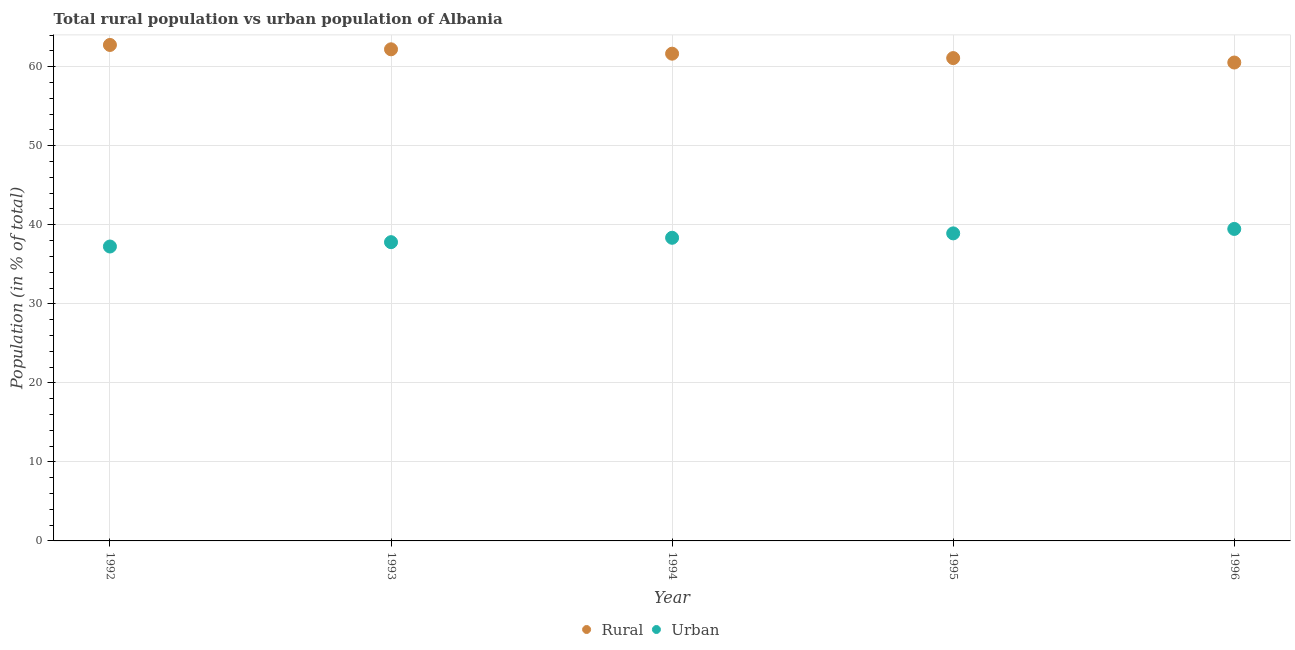How many different coloured dotlines are there?
Offer a very short reply. 2. Is the number of dotlines equal to the number of legend labels?
Your response must be concise. Yes. What is the urban population in 1993?
Offer a very short reply. 37.8. Across all years, what is the maximum rural population?
Give a very brief answer. 62.75. Across all years, what is the minimum rural population?
Offer a terse response. 60.53. In which year was the rural population maximum?
Ensure brevity in your answer.  1992. What is the total rural population in the graph?
Make the answer very short. 308.21. What is the difference between the rural population in 1995 and that in 1996?
Offer a very short reply. 0.56. What is the difference between the rural population in 1993 and the urban population in 1992?
Provide a short and direct response. 24.95. What is the average urban population per year?
Provide a short and direct response. 38.36. In the year 1996, what is the difference between the urban population and rural population?
Your answer should be very brief. -21.05. What is the ratio of the rural population in 1992 to that in 1995?
Offer a terse response. 1.03. Is the difference between the rural population in 1993 and 1994 greater than the difference between the urban population in 1993 and 1994?
Provide a short and direct response. Yes. What is the difference between the highest and the second highest urban population?
Your answer should be compact. 0.56. What is the difference between the highest and the lowest urban population?
Make the answer very short. 2.22. In how many years, is the rural population greater than the average rural population taken over all years?
Your response must be concise. 3. Does the rural population monotonically increase over the years?
Ensure brevity in your answer.  No. How many dotlines are there?
Your response must be concise. 2. Does the graph contain any zero values?
Give a very brief answer. No. Does the graph contain grids?
Your response must be concise. Yes. How many legend labels are there?
Offer a very short reply. 2. What is the title of the graph?
Your answer should be very brief. Total rural population vs urban population of Albania. Does "US$" appear as one of the legend labels in the graph?
Keep it short and to the point. No. What is the label or title of the Y-axis?
Provide a short and direct response. Population (in % of total). What is the Population (in % of total) in Rural in 1992?
Provide a short and direct response. 62.75. What is the Population (in % of total) in Urban in 1992?
Give a very brief answer. 37.25. What is the Population (in % of total) in Rural in 1993?
Provide a succinct answer. 62.2. What is the Population (in % of total) of Urban in 1993?
Give a very brief answer. 37.8. What is the Population (in % of total) of Rural in 1994?
Ensure brevity in your answer.  61.65. What is the Population (in % of total) of Urban in 1994?
Your answer should be compact. 38.35. What is the Population (in % of total) of Rural in 1995?
Offer a terse response. 61.09. What is the Population (in % of total) in Urban in 1995?
Give a very brief answer. 38.91. What is the Population (in % of total) in Rural in 1996?
Keep it short and to the point. 60.53. What is the Population (in % of total) of Urban in 1996?
Provide a short and direct response. 39.47. Across all years, what is the maximum Population (in % of total) in Rural?
Make the answer very short. 62.75. Across all years, what is the maximum Population (in % of total) of Urban?
Give a very brief answer. 39.47. Across all years, what is the minimum Population (in % of total) of Rural?
Your answer should be compact. 60.53. Across all years, what is the minimum Population (in % of total) of Urban?
Your response must be concise. 37.25. What is the total Population (in % of total) of Rural in the graph?
Provide a succinct answer. 308.21. What is the total Population (in % of total) of Urban in the graph?
Give a very brief answer. 191.79. What is the difference between the Population (in % of total) of Rural in 1992 and that in 1993?
Offer a very short reply. 0.55. What is the difference between the Population (in % of total) in Urban in 1992 and that in 1993?
Your answer should be very brief. -0.55. What is the difference between the Population (in % of total) of Rural in 1992 and that in 1994?
Give a very brief answer. 1.1. What is the difference between the Population (in % of total) in Urban in 1992 and that in 1994?
Provide a short and direct response. -1.1. What is the difference between the Population (in % of total) of Rural in 1992 and that in 1995?
Ensure brevity in your answer.  1.66. What is the difference between the Population (in % of total) of Urban in 1992 and that in 1995?
Offer a terse response. -1.66. What is the difference between the Population (in % of total) in Rural in 1992 and that in 1996?
Provide a short and direct response. 2.22. What is the difference between the Population (in % of total) in Urban in 1992 and that in 1996?
Give a very brief answer. -2.22. What is the difference between the Population (in % of total) of Rural in 1993 and that in 1994?
Your answer should be compact. 0.56. What is the difference between the Population (in % of total) in Urban in 1993 and that in 1994?
Give a very brief answer. -0.56. What is the difference between the Population (in % of total) of Rural in 1993 and that in 1995?
Your answer should be compact. 1.11. What is the difference between the Population (in % of total) in Urban in 1993 and that in 1995?
Keep it short and to the point. -1.11. What is the difference between the Population (in % of total) of Rural in 1993 and that in 1996?
Your answer should be compact. 1.67. What is the difference between the Population (in % of total) in Urban in 1993 and that in 1996?
Make the answer very short. -1.67. What is the difference between the Population (in % of total) of Rural in 1994 and that in 1995?
Make the answer very short. 0.56. What is the difference between the Population (in % of total) of Urban in 1994 and that in 1995?
Keep it short and to the point. -0.56. What is the difference between the Population (in % of total) of Rural in 1994 and that in 1996?
Your answer should be very brief. 1.12. What is the difference between the Population (in % of total) in Urban in 1994 and that in 1996?
Make the answer very short. -1.12. What is the difference between the Population (in % of total) of Rural in 1995 and that in 1996?
Make the answer very short. 0.56. What is the difference between the Population (in % of total) of Urban in 1995 and that in 1996?
Your response must be concise. -0.56. What is the difference between the Population (in % of total) of Rural in 1992 and the Population (in % of total) of Urban in 1993?
Offer a terse response. 24.95. What is the difference between the Population (in % of total) of Rural in 1992 and the Population (in % of total) of Urban in 1994?
Give a very brief answer. 24.4. What is the difference between the Population (in % of total) in Rural in 1992 and the Population (in % of total) in Urban in 1995?
Make the answer very short. 23.84. What is the difference between the Population (in % of total) of Rural in 1992 and the Population (in % of total) of Urban in 1996?
Ensure brevity in your answer.  23.28. What is the difference between the Population (in % of total) in Rural in 1993 and the Population (in % of total) in Urban in 1994?
Your answer should be compact. 23.85. What is the difference between the Population (in % of total) in Rural in 1993 and the Population (in % of total) in Urban in 1995?
Offer a very short reply. 23.29. What is the difference between the Population (in % of total) in Rural in 1993 and the Population (in % of total) in Urban in 1996?
Provide a short and direct response. 22.73. What is the difference between the Population (in % of total) in Rural in 1994 and the Population (in % of total) in Urban in 1995?
Provide a short and direct response. 22.73. What is the difference between the Population (in % of total) in Rural in 1994 and the Population (in % of total) in Urban in 1996?
Your answer should be compact. 22.17. What is the difference between the Population (in % of total) of Rural in 1995 and the Population (in % of total) of Urban in 1996?
Offer a terse response. 21.62. What is the average Population (in % of total) in Rural per year?
Provide a succinct answer. 61.64. What is the average Population (in % of total) of Urban per year?
Ensure brevity in your answer.  38.36. In the year 1992, what is the difference between the Population (in % of total) of Rural and Population (in % of total) of Urban?
Give a very brief answer. 25.5. In the year 1993, what is the difference between the Population (in % of total) of Rural and Population (in % of total) of Urban?
Ensure brevity in your answer.  24.4. In the year 1994, what is the difference between the Population (in % of total) in Rural and Population (in % of total) in Urban?
Provide a succinct answer. 23.29. In the year 1995, what is the difference between the Population (in % of total) in Rural and Population (in % of total) in Urban?
Give a very brief answer. 22.18. In the year 1996, what is the difference between the Population (in % of total) of Rural and Population (in % of total) of Urban?
Keep it short and to the point. 21.05. What is the ratio of the Population (in % of total) in Rural in 1992 to that in 1993?
Provide a short and direct response. 1.01. What is the ratio of the Population (in % of total) of Urban in 1992 to that in 1993?
Offer a very short reply. 0.99. What is the ratio of the Population (in % of total) of Rural in 1992 to that in 1994?
Offer a terse response. 1.02. What is the ratio of the Population (in % of total) of Urban in 1992 to that in 1994?
Keep it short and to the point. 0.97. What is the ratio of the Population (in % of total) of Rural in 1992 to that in 1995?
Ensure brevity in your answer.  1.03. What is the ratio of the Population (in % of total) of Urban in 1992 to that in 1995?
Make the answer very short. 0.96. What is the ratio of the Population (in % of total) in Rural in 1992 to that in 1996?
Provide a succinct answer. 1.04. What is the ratio of the Population (in % of total) of Urban in 1992 to that in 1996?
Your answer should be very brief. 0.94. What is the ratio of the Population (in % of total) in Rural in 1993 to that in 1994?
Make the answer very short. 1.01. What is the ratio of the Population (in % of total) in Urban in 1993 to that in 1994?
Ensure brevity in your answer.  0.99. What is the ratio of the Population (in % of total) of Rural in 1993 to that in 1995?
Provide a short and direct response. 1.02. What is the ratio of the Population (in % of total) in Urban in 1993 to that in 1995?
Ensure brevity in your answer.  0.97. What is the ratio of the Population (in % of total) of Rural in 1993 to that in 1996?
Ensure brevity in your answer.  1.03. What is the ratio of the Population (in % of total) of Urban in 1993 to that in 1996?
Ensure brevity in your answer.  0.96. What is the ratio of the Population (in % of total) of Rural in 1994 to that in 1995?
Offer a very short reply. 1.01. What is the ratio of the Population (in % of total) in Urban in 1994 to that in 1995?
Offer a very short reply. 0.99. What is the ratio of the Population (in % of total) in Rural in 1994 to that in 1996?
Your answer should be compact. 1.02. What is the ratio of the Population (in % of total) in Urban in 1994 to that in 1996?
Your answer should be compact. 0.97. What is the ratio of the Population (in % of total) of Rural in 1995 to that in 1996?
Keep it short and to the point. 1.01. What is the ratio of the Population (in % of total) in Urban in 1995 to that in 1996?
Provide a short and direct response. 0.99. What is the difference between the highest and the second highest Population (in % of total) in Rural?
Your response must be concise. 0.55. What is the difference between the highest and the second highest Population (in % of total) in Urban?
Make the answer very short. 0.56. What is the difference between the highest and the lowest Population (in % of total) in Rural?
Your answer should be compact. 2.22. What is the difference between the highest and the lowest Population (in % of total) in Urban?
Make the answer very short. 2.22. 